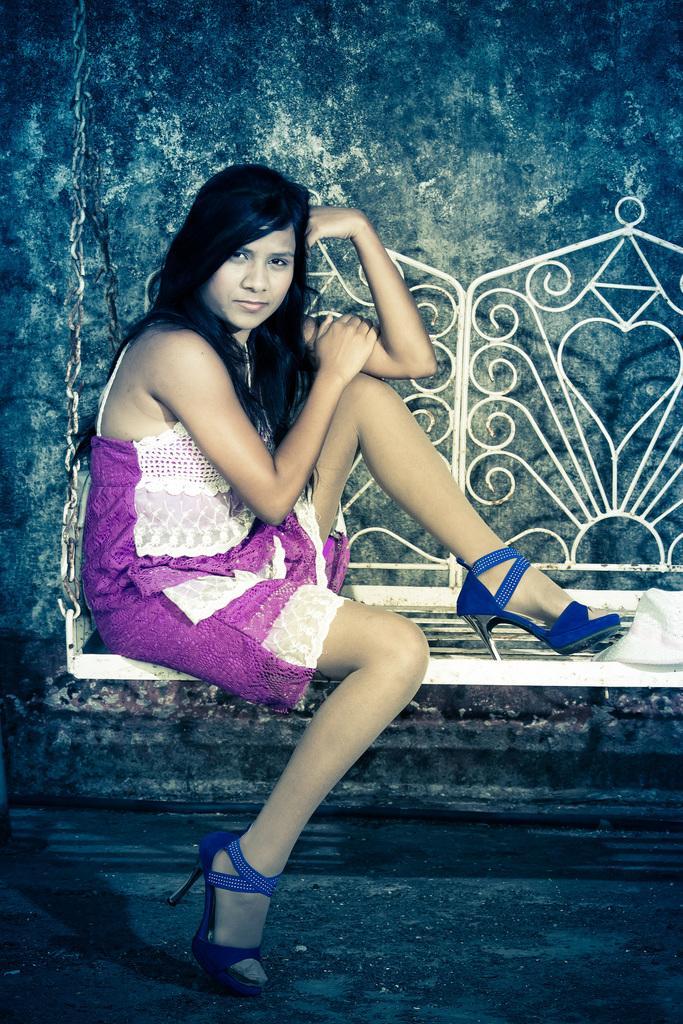Describe this image in one or two sentences. In this picture I can see a woman sitting on a swing in front and I see that she is wearing white and pink color dress. In the background I can see the wall. 